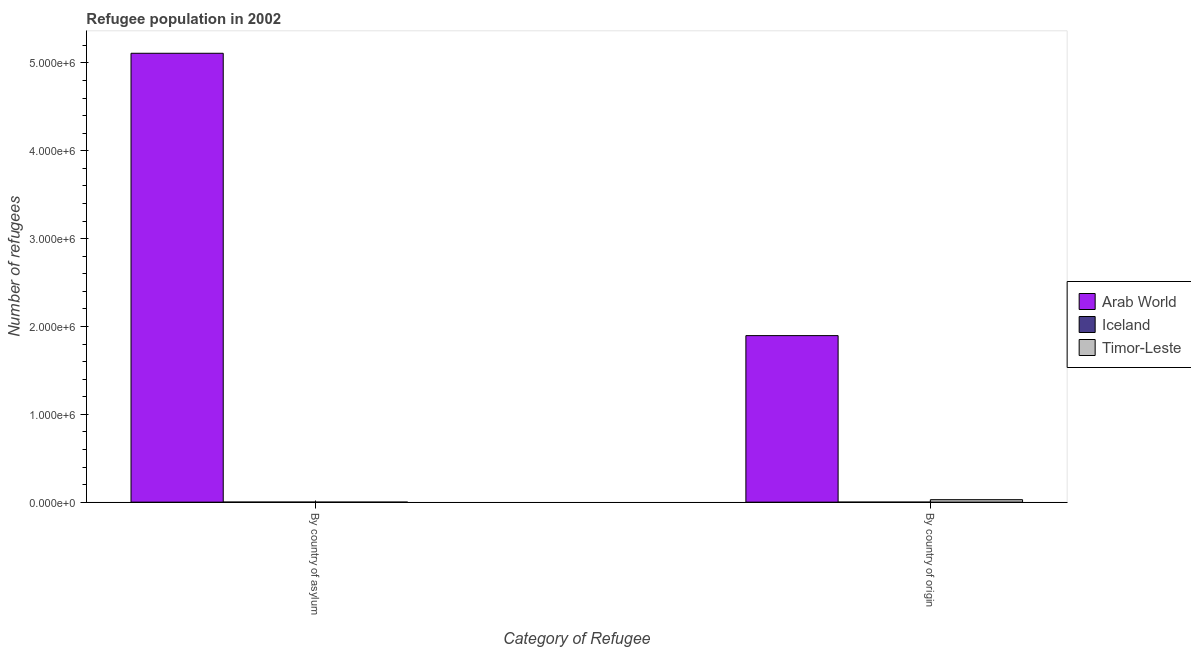How many different coloured bars are there?
Provide a succinct answer. 3. How many groups of bars are there?
Offer a terse response. 2. Are the number of bars per tick equal to the number of legend labels?
Make the answer very short. Yes. Are the number of bars on each tick of the X-axis equal?
Your answer should be compact. Yes. What is the label of the 2nd group of bars from the left?
Keep it short and to the point. By country of origin. What is the number of refugees by country of origin in Iceland?
Ensure brevity in your answer.  13. Across all countries, what is the maximum number of refugees by country of origin?
Ensure brevity in your answer.  1.90e+06. Across all countries, what is the minimum number of refugees by country of origin?
Provide a short and direct response. 13. In which country was the number of refugees by country of asylum maximum?
Your answer should be compact. Arab World. In which country was the number of refugees by country of origin minimum?
Keep it short and to the point. Iceland. What is the total number of refugees by country of origin in the graph?
Your response must be concise. 1.92e+06. What is the difference between the number of refugees by country of origin in Iceland and that in Timor-Leste?
Your response must be concise. -2.81e+04. What is the difference between the number of refugees by country of asylum in Timor-Leste and the number of refugees by country of origin in Arab World?
Ensure brevity in your answer.  -1.90e+06. What is the average number of refugees by country of origin per country?
Provide a short and direct response. 6.41e+05. What is the difference between the number of refugees by country of origin and number of refugees by country of asylum in Timor-Leste?
Offer a terse response. 2.81e+04. What is the ratio of the number of refugees by country of origin in Timor-Leste to that in Arab World?
Give a very brief answer. 0.01. Is the number of refugees by country of asylum in Timor-Leste less than that in Arab World?
Keep it short and to the point. Yes. In how many countries, is the number of refugees by country of asylum greater than the average number of refugees by country of asylum taken over all countries?
Ensure brevity in your answer.  1. What does the 1st bar from the left in By country of asylum represents?
Provide a succinct answer. Arab World. How many bars are there?
Keep it short and to the point. 6. Does the graph contain grids?
Keep it short and to the point. No. Where does the legend appear in the graph?
Offer a terse response. Center right. How many legend labels are there?
Offer a terse response. 3. How are the legend labels stacked?
Your answer should be very brief. Vertical. What is the title of the graph?
Provide a short and direct response. Refugee population in 2002. Does "Middle East & North Africa (all income levels)" appear as one of the legend labels in the graph?
Provide a succinct answer. No. What is the label or title of the X-axis?
Ensure brevity in your answer.  Category of Refugee. What is the label or title of the Y-axis?
Offer a very short reply. Number of refugees. What is the Number of refugees in Arab World in By country of asylum?
Offer a very short reply. 5.11e+06. What is the Number of refugees of Iceland in By country of asylum?
Provide a short and direct response. 207. What is the Number of refugees of Arab World in By country of origin?
Offer a very short reply. 1.90e+06. What is the Number of refugees in Iceland in By country of origin?
Make the answer very short. 13. What is the Number of refugees in Timor-Leste in By country of origin?
Make the answer very short. 2.81e+04. Across all Category of Refugee, what is the maximum Number of refugees in Arab World?
Your answer should be compact. 5.11e+06. Across all Category of Refugee, what is the maximum Number of refugees of Iceland?
Your answer should be compact. 207. Across all Category of Refugee, what is the maximum Number of refugees in Timor-Leste?
Offer a terse response. 2.81e+04. Across all Category of Refugee, what is the minimum Number of refugees of Arab World?
Provide a succinct answer. 1.90e+06. What is the total Number of refugees of Arab World in the graph?
Give a very brief answer. 7.01e+06. What is the total Number of refugees of Iceland in the graph?
Provide a short and direct response. 220. What is the total Number of refugees in Timor-Leste in the graph?
Offer a very short reply. 2.81e+04. What is the difference between the Number of refugees of Arab World in By country of asylum and that in By country of origin?
Keep it short and to the point. 3.21e+06. What is the difference between the Number of refugees in Iceland in By country of asylum and that in By country of origin?
Your answer should be very brief. 194. What is the difference between the Number of refugees in Timor-Leste in By country of asylum and that in By country of origin?
Your answer should be very brief. -2.81e+04. What is the difference between the Number of refugees in Arab World in By country of asylum and the Number of refugees in Iceland in By country of origin?
Ensure brevity in your answer.  5.11e+06. What is the difference between the Number of refugees in Arab World in By country of asylum and the Number of refugees in Timor-Leste in By country of origin?
Keep it short and to the point. 5.08e+06. What is the difference between the Number of refugees in Iceland in By country of asylum and the Number of refugees in Timor-Leste in By country of origin?
Ensure brevity in your answer.  -2.79e+04. What is the average Number of refugees in Arab World per Category of Refugee?
Your response must be concise. 3.50e+06. What is the average Number of refugees of Iceland per Category of Refugee?
Your answer should be compact. 110. What is the average Number of refugees in Timor-Leste per Category of Refugee?
Make the answer very short. 1.40e+04. What is the difference between the Number of refugees in Arab World and Number of refugees in Iceland in By country of asylum?
Your answer should be very brief. 5.11e+06. What is the difference between the Number of refugees in Arab World and Number of refugees in Timor-Leste in By country of asylum?
Provide a succinct answer. 5.11e+06. What is the difference between the Number of refugees in Iceland and Number of refugees in Timor-Leste in By country of asylum?
Ensure brevity in your answer.  206. What is the difference between the Number of refugees of Arab World and Number of refugees of Iceland in By country of origin?
Provide a succinct answer. 1.90e+06. What is the difference between the Number of refugees in Arab World and Number of refugees in Timor-Leste in By country of origin?
Provide a succinct answer. 1.87e+06. What is the difference between the Number of refugees in Iceland and Number of refugees in Timor-Leste in By country of origin?
Your answer should be very brief. -2.81e+04. What is the ratio of the Number of refugees of Arab World in By country of asylum to that in By country of origin?
Provide a short and direct response. 2.7. What is the ratio of the Number of refugees of Iceland in By country of asylum to that in By country of origin?
Your answer should be compact. 15.92. What is the difference between the highest and the second highest Number of refugees of Arab World?
Your answer should be compact. 3.21e+06. What is the difference between the highest and the second highest Number of refugees of Iceland?
Your answer should be very brief. 194. What is the difference between the highest and the second highest Number of refugees in Timor-Leste?
Your response must be concise. 2.81e+04. What is the difference between the highest and the lowest Number of refugees in Arab World?
Give a very brief answer. 3.21e+06. What is the difference between the highest and the lowest Number of refugees of Iceland?
Provide a short and direct response. 194. What is the difference between the highest and the lowest Number of refugees in Timor-Leste?
Ensure brevity in your answer.  2.81e+04. 